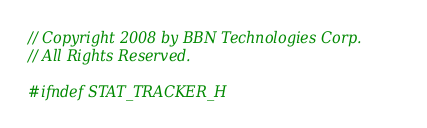Convert code to text. <code><loc_0><loc_0><loc_500><loc_500><_C_>// Copyright 2008 by BBN Technologies Corp.
// All Rights Reserved.

#ifndef STAT_TRACKER_H</code> 